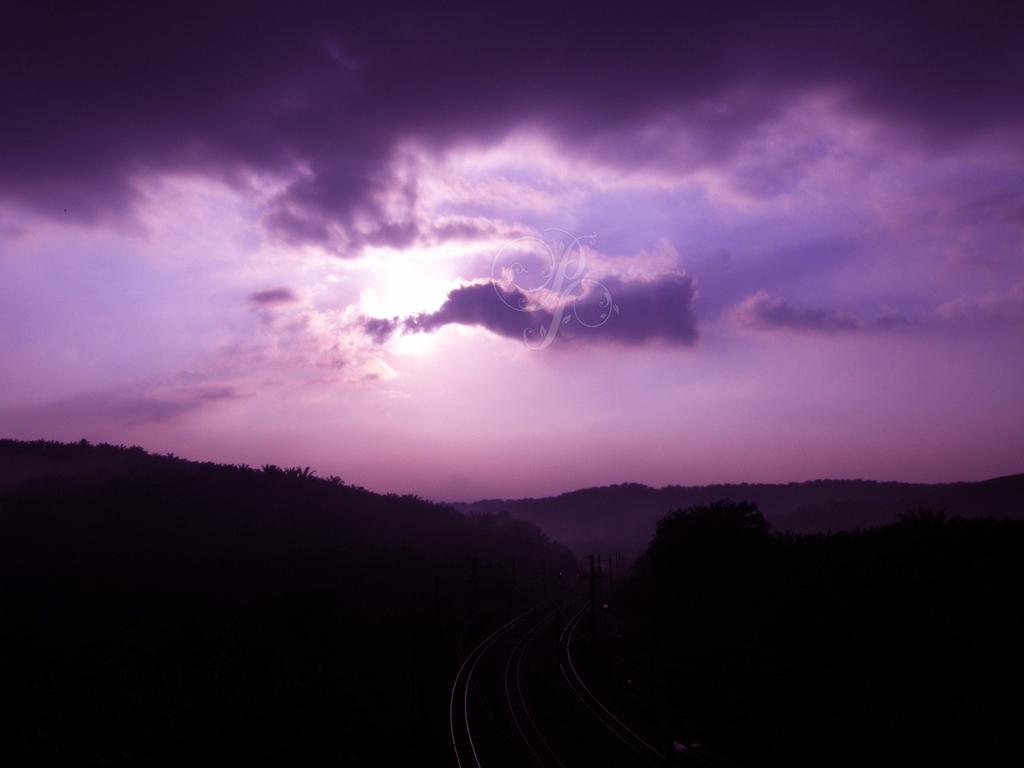How would you summarize this image in a sentence or two? Here in this picture, in the front we can see railway tracks present on the ground and we can see hills covered with trees and plants and in the sky we can see clouds and sun present over there. 